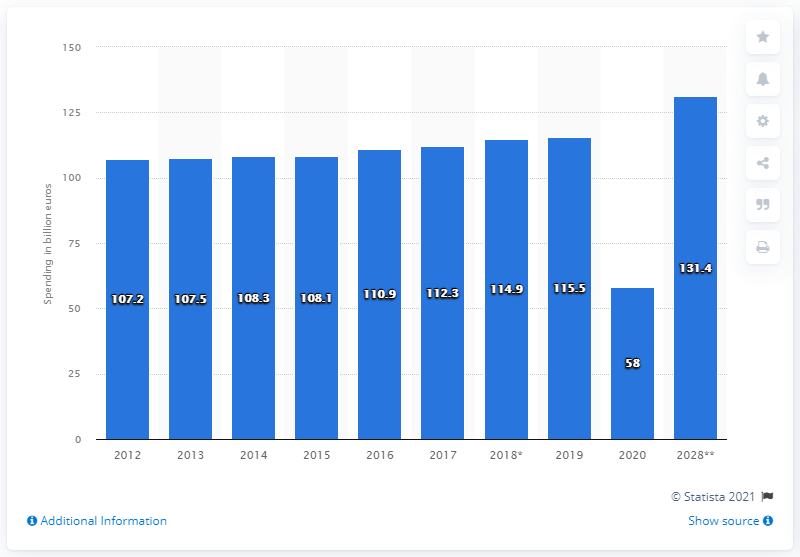Can you tell me how domestic tourism expenditure fluctuated from 2018 to 2020? Certainly! According to the chart, domestic tourism expenditure saw a rise from 2018, with a spending of 114.9 billion dollars, to 115.5 billion dollars in 2019. However, there was a notable decrease in 2020, where expenditure plummeted to just 58 billion dollars, likely due to the impact of global events during that time. 